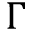Convert formula to latex. <formula><loc_0><loc_0><loc_500><loc_500>\Gamma</formula> 